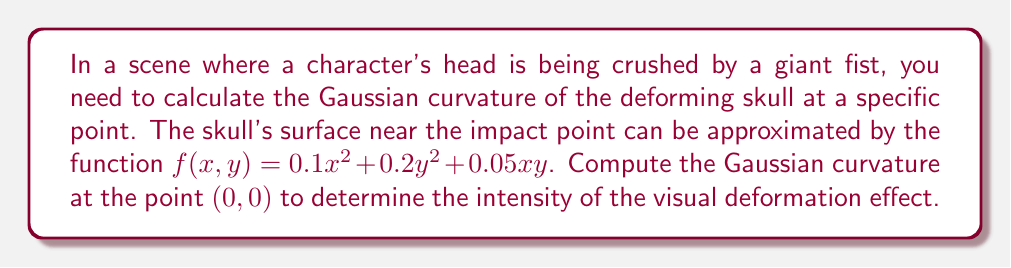What is the answer to this math problem? To calculate the Gaussian curvature of the surface $z = f(x,y) = 0.1x^2 + 0.2y^2 + 0.05xy$ at the point (0,0), we'll follow these steps:

1) The Gaussian curvature K is given by the formula:

   $$K = \frac{f_{xx}f_{yy} - f_{xy}^2}{(1 + f_x^2 + f_y^2)^2}$$

   where $f_x, f_y$ are first partial derivatives, and $f_{xx}, f_{yy}, f_{xy}$ are second partial derivatives.

2) Calculate the partial derivatives:
   $f_x = 0.2x + 0.05y$
   $f_y = 0.4y + 0.05x$
   $f_{xx} = 0.2$
   $f_{yy} = 0.4$
   $f_{xy} = 0.05$

3) At the point (0,0):
   $f_x(0,0) = 0$
   $f_y(0,0) = 0$
   $f_{xx}(0,0) = 0.2$
   $f_{yy}(0,0) = 0.4$
   $f_{xy}(0,0) = 0.05$

4) Substitute these values into the Gaussian curvature formula:

   $$K = \frac{(0.2)(0.4) - (0.05)^2}{(1 + 0^2 + 0^2)^2} = \frac{0.08 - 0.0025}{1} = 0.0775$$

5) The Gaussian curvature at (0,0) is 0.0775.
Answer: $K = 0.0775$ 